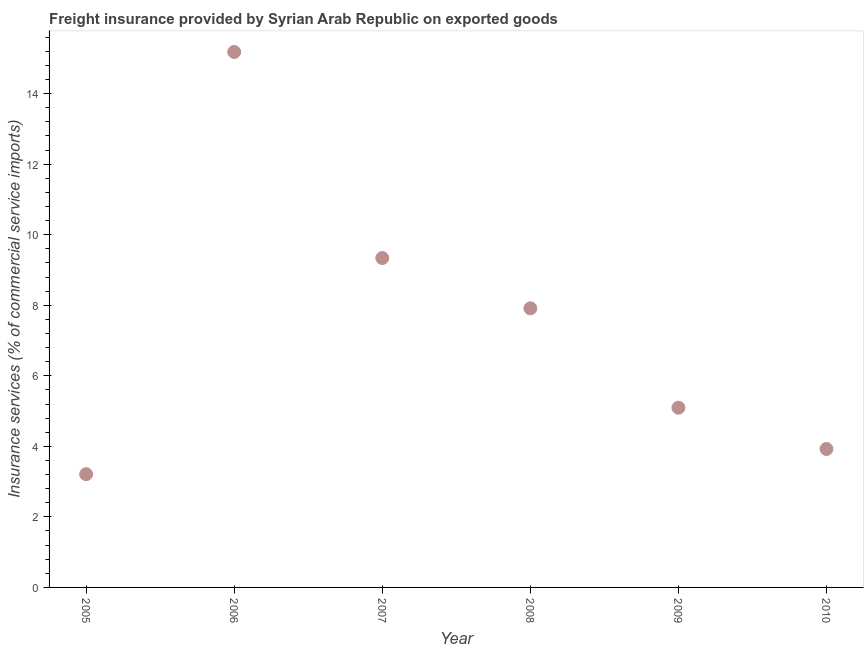What is the freight insurance in 2010?
Provide a short and direct response. 3.93. Across all years, what is the maximum freight insurance?
Your answer should be very brief. 15.18. Across all years, what is the minimum freight insurance?
Offer a very short reply. 3.21. What is the sum of the freight insurance?
Keep it short and to the point. 44.66. What is the difference between the freight insurance in 2006 and 2009?
Provide a succinct answer. 10.09. What is the average freight insurance per year?
Your response must be concise. 7.44. What is the median freight insurance?
Make the answer very short. 6.5. In how many years, is the freight insurance greater than 1.2000000000000002 %?
Your response must be concise. 6. Do a majority of the years between 2010 and 2008 (inclusive) have freight insurance greater than 8.4 %?
Give a very brief answer. No. What is the ratio of the freight insurance in 2007 to that in 2008?
Your response must be concise. 1.18. Is the freight insurance in 2005 less than that in 2009?
Ensure brevity in your answer.  Yes. What is the difference between the highest and the second highest freight insurance?
Your answer should be very brief. 5.84. What is the difference between the highest and the lowest freight insurance?
Give a very brief answer. 11.97. In how many years, is the freight insurance greater than the average freight insurance taken over all years?
Your answer should be compact. 3. Does the freight insurance monotonically increase over the years?
Give a very brief answer. No. How many dotlines are there?
Offer a terse response. 1. What is the difference between two consecutive major ticks on the Y-axis?
Ensure brevity in your answer.  2. Does the graph contain any zero values?
Your answer should be compact. No. Does the graph contain grids?
Keep it short and to the point. No. What is the title of the graph?
Keep it short and to the point. Freight insurance provided by Syrian Arab Republic on exported goods . What is the label or title of the Y-axis?
Provide a succinct answer. Insurance services (% of commercial service imports). What is the Insurance services (% of commercial service imports) in 2005?
Provide a succinct answer. 3.21. What is the Insurance services (% of commercial service imports) in 2006?
Offer a very short reply. 15.18. What is the Insurance services (% of commercial service imports) in 2007?
Your response must be concise. 9.34. What is the Insurance services (% of commercial service imports) in 2008?
Make the answer very short. 7.91. What is the Insurance services (% of commercial service imports) in 2009?
Offer a very short reply. 5.09. What is the Insurance services (% of commercial service imports) in 2010?
Offer a terse response. 3.93. What is the difference between the Insurance services (% of commercial service imports) in 2005 and 2006?
Provide a succinct answer. -11.97. What is the difference between the Insurance services (% of commercial service imports) in 2005 and 2007?
Offer a terse response. -6.13. What is the difference between the Insurance services (% of commercial service imports) in 2005 and 2008?
Your answer should be compact. -4.7. What is the difference between the Insurance services (% of commercial service imports) in 2005 and 2009?
Your response must be concise. -1.88. What is the difference between the Insurance services (% of commercial service imports) in 2005 and 2010?
Offer a very short reply. -0.72. What is the difference between the Insurance services (% of commercial service imports) in 2006 and 2007?
Give a very brief answer. 5.84. What is the difference between the Insurance services (% of commercial service imports) in 2006 and 2008?
Keep it short and to the point. 7.27. What is the difference between the Insurance services (% of commercial service imports) in 2006 and 2009?
Offer a terse response. 10.09. What is the difference between the Insurance services (% of commercial service imports) in 2006 and 2010?
Give a very brief answer. 11.26. What is the difference between the Insurance services (% of commercial service imports) in 2007 and 2008?
Your answer should be very brief. 1.43. What is the difference between the Insurance services (% of commercial service imports) in 2007 and 2009?
Ensure brevity in your answer.  4.25. What is the difference between the Insurance services (% of commercial service imports) in 2007 and 2010?
Offer a terse response. 5.41. What is the difference between the Insurance services (% of commercial service imports) in 2008 and 2009?
Provide a short and direct response. 2.82. What is the difference between the Insurance services (% of commercial service imports) in 2008 and 2010?
Offer a terse response. 3.99. What is the difference between the Insurance services (% of commercial service imports) in 2009 and 2010?
Provide a succinct answer. 1.17. What is the ratio of the Insurance services (% of commercial service imports) in 2005 to that in 2006?
Offer a terse response. 0.21. What is the ratio of the Insurance services (% of commercial service imports) in 2005 to that in 2007?
Give a very brief answer. 0.34. What is the ratio of the Insurance services (% of commercial service imports) in 2005 to that in 2008?
Offer a very short reply. 0.41. What is the ratio of the Insurance services (% of commercial service imports) in 2005 to that in 2009?
Provide a short and direct response. 0.63. What is the ratio of the Insurance services (% of commercial service imports) in 2005 to that in 2010?
Your answer should be compact. 0.82. What is the ratio of the Insurance services (% of commercial service imports) in 2006 to that in 2007?
Your response must be concise. 1.63. What is the ratio of the Insurance services (% of commercial service imports) in 2006 to that in 2008?
Make the answer very short. 1.92. What is the ratio of the Insurance services (% of commercial service imports) in 2006 to that in 2009?
Give a very brief answer. 2.98. What is the ratio of the Insurance services (% of commercial service imports) in 2006 to that in 2010?
Give a very brief answer. 3.87. What is the ratio of the Insurance services (% of commercial service imports) in 2007 to that in 2008?
Your answer should be compact. 1.18. What is the ratio of the Insurance services (% of commercial service imports) in 2007 to that in 2009?
Ensure brevity in your answer.  1.83. What is the ratio of the Insurance services (% of commercial service imports) in 2007 to that in 2010?
Keep it short and to the point. 2.38. What is the ratio of the Insurance services (% of commercial service imports) in 2008 to that in 2009?
Provide a succinct answer. 1.55. What is the ratio of the Insurance services (% of commercial service imports) in 2008 to that in 2010?
Your answer should be compact. 2.02. What is the ratio of the Insurance services (% of commercial service imports) in 2009 to that in 2010?
Give a very brief answer. 1.3. 